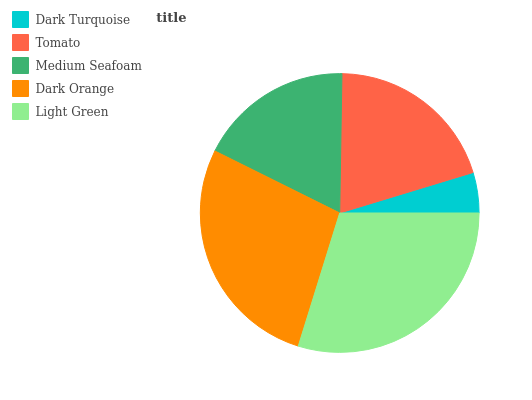Is Dark Turquoise the minimum?
Answer yes or no. Yes. Is Light Green the maximum?
Answer yes or no. Yes. Is Tomato the minimum?
Answer yes or no. No. Is Tomato the maximum?
Answer yes or no. No. Is Tomato greater than Dark Turquoise?
Answer yes or no. Yes. Is Dark Turquoise less than Tomato?
Answer yes or no. Yes. Is Dark Turquoise greater than Tomato?
Answer yes or no. No. Is Tomato less than Dark Turquoise?
Answer yes or no. No. Is Tomato the high median?
Answer yes or no. Yes. Is Tomato the low median?
Answer yes or no. Yes. Is Dark Turquoise the high median?
Answer yes or no. No. Is Dark Turquoise the low median?
Answer yes or no. No. 